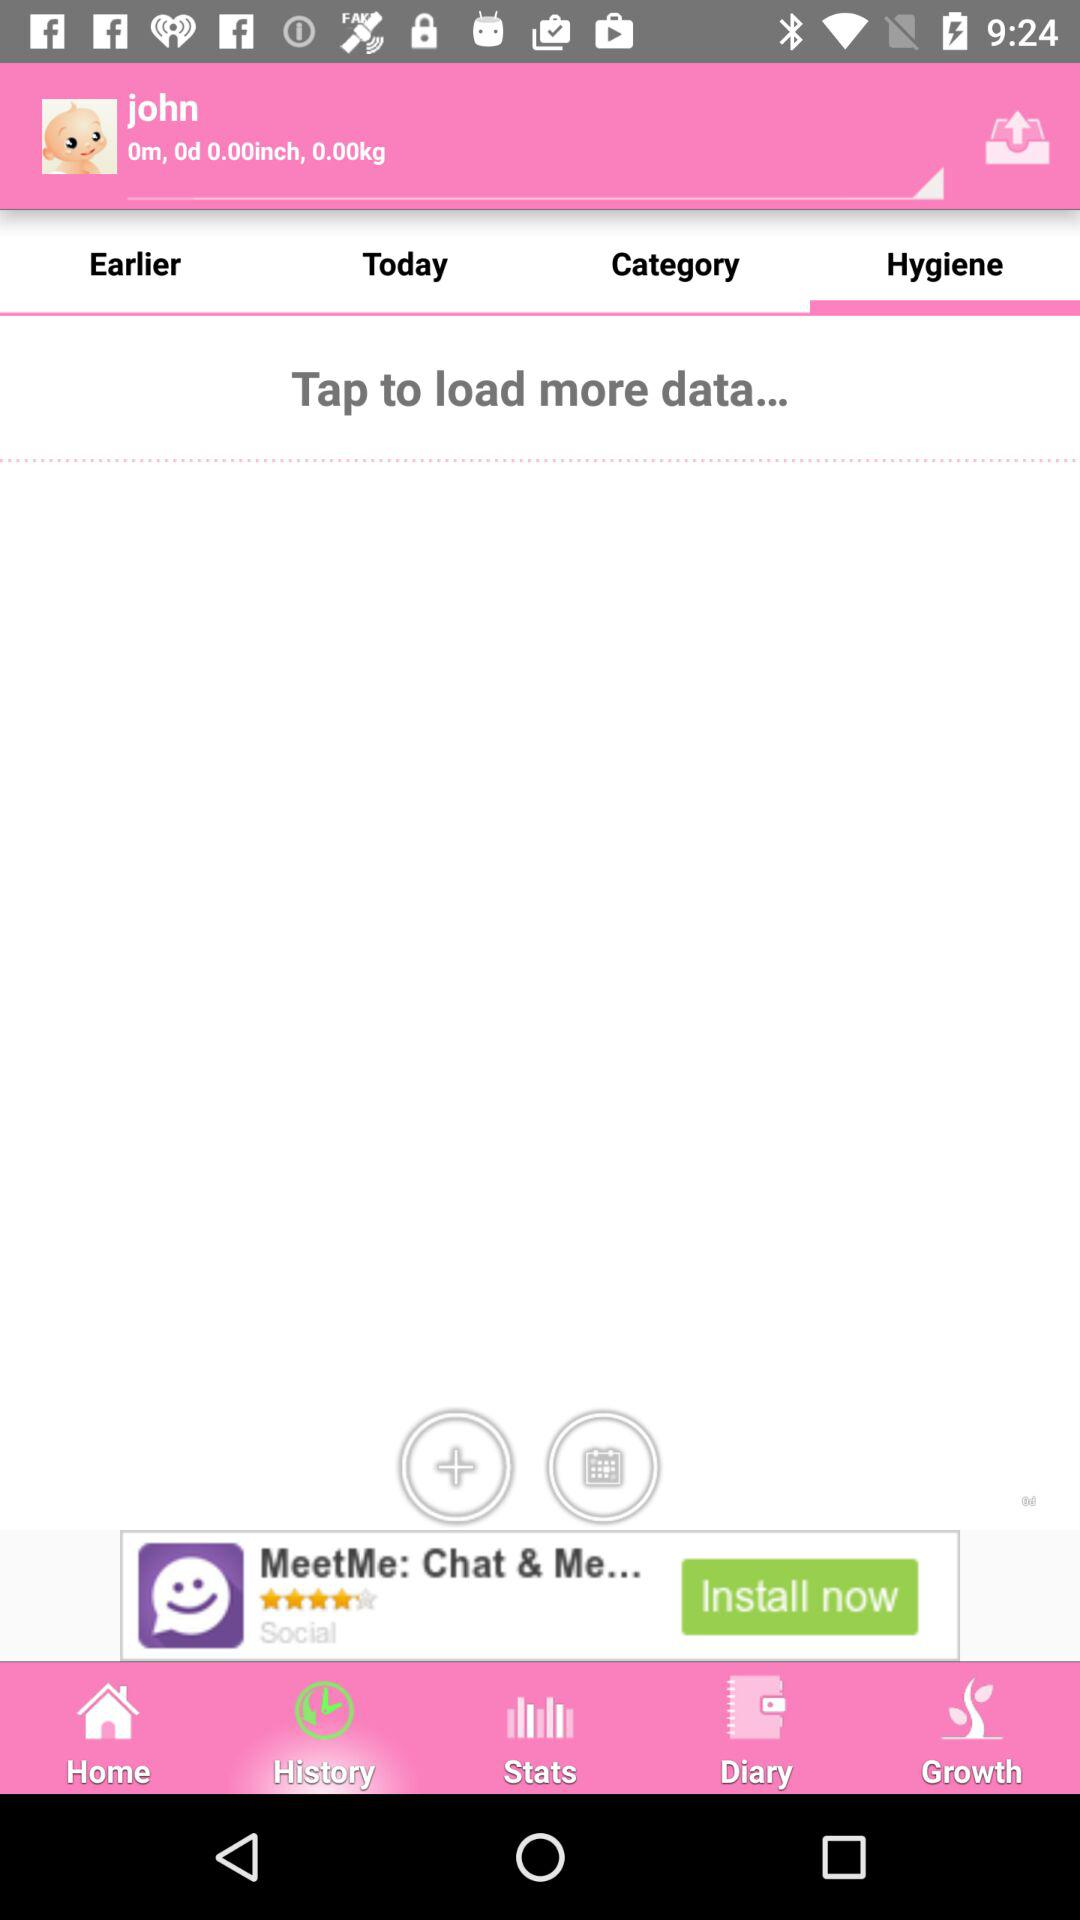What's the name? The name is John. 